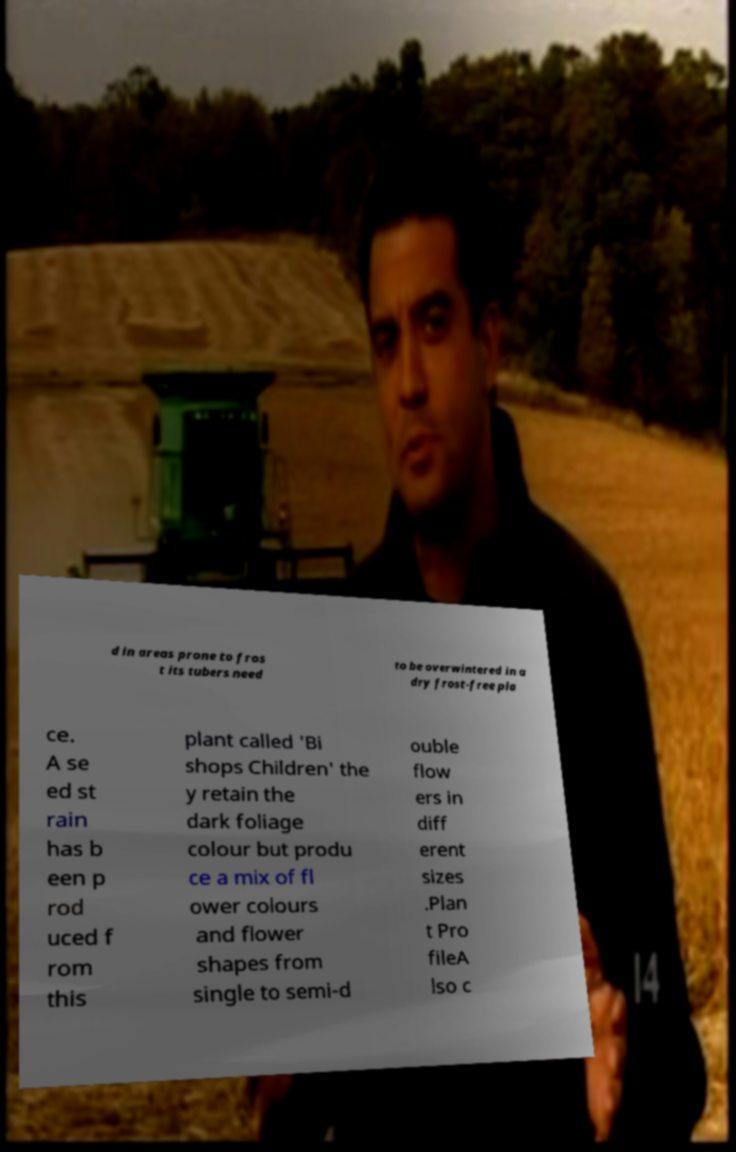What messages or text are displayed in this image? I need them in a readable, typed format. d in areas prone to fros t its tubers need to be overwintered in a dry frost-free pla ce. A se ed st rain has b een p rod uced f rom this plant called 'Bi shops Children' the y retain the dark foliage colour but produ ce a mix of fl ower colours and flower shapes from single to semi-d ouble flow ers in diff erent sizes .Plan t Pro fileA lso c 